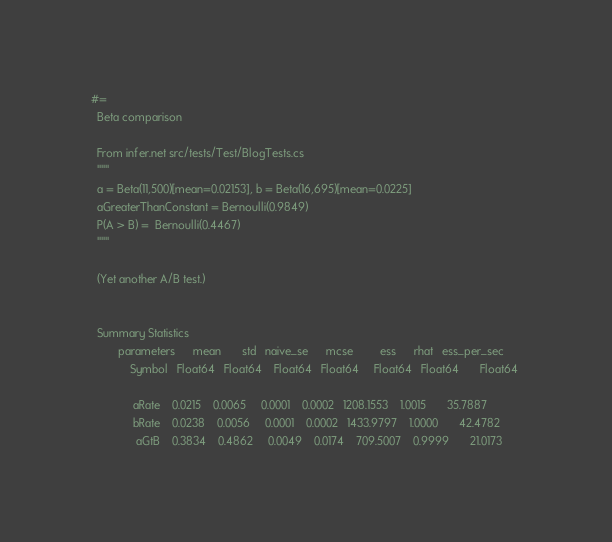Convert code to text. <code><loc_0><loc_0><loc_500><loc_500><_Julia_>#=
  Beta comparison

  From infer.net src/tests/Test/BlogTests.cs
  """
  a = Beta(11,500)[mean=0.02153], b = Beta(16,695)[mean=0.0225]
  aGreaterThanConstant = Bernoulli(0.9849)
  P(A > B) =  Bernoulli(0.4467)
  """

  (Yet another A/B test.)


  Summary Statistics
         parameters      mean       std   naive_se      mcse         ess      rhat   ess_per_sec 
             Symbol   Float64   Float64    Float64   Float64     Float64   Float64       Float64 

              aRate    0.0215    0.0065     0.0001    0.0002   1208.1553    1.0015       35.7887
              bRate    0.0238    0.0056     0.0001    0.0002   1433.9797    1.0000       42.4782
               aGtB    0.3834    0.4862     0.0049    0.0174    709.5007    0.9999       21.0173</code> 